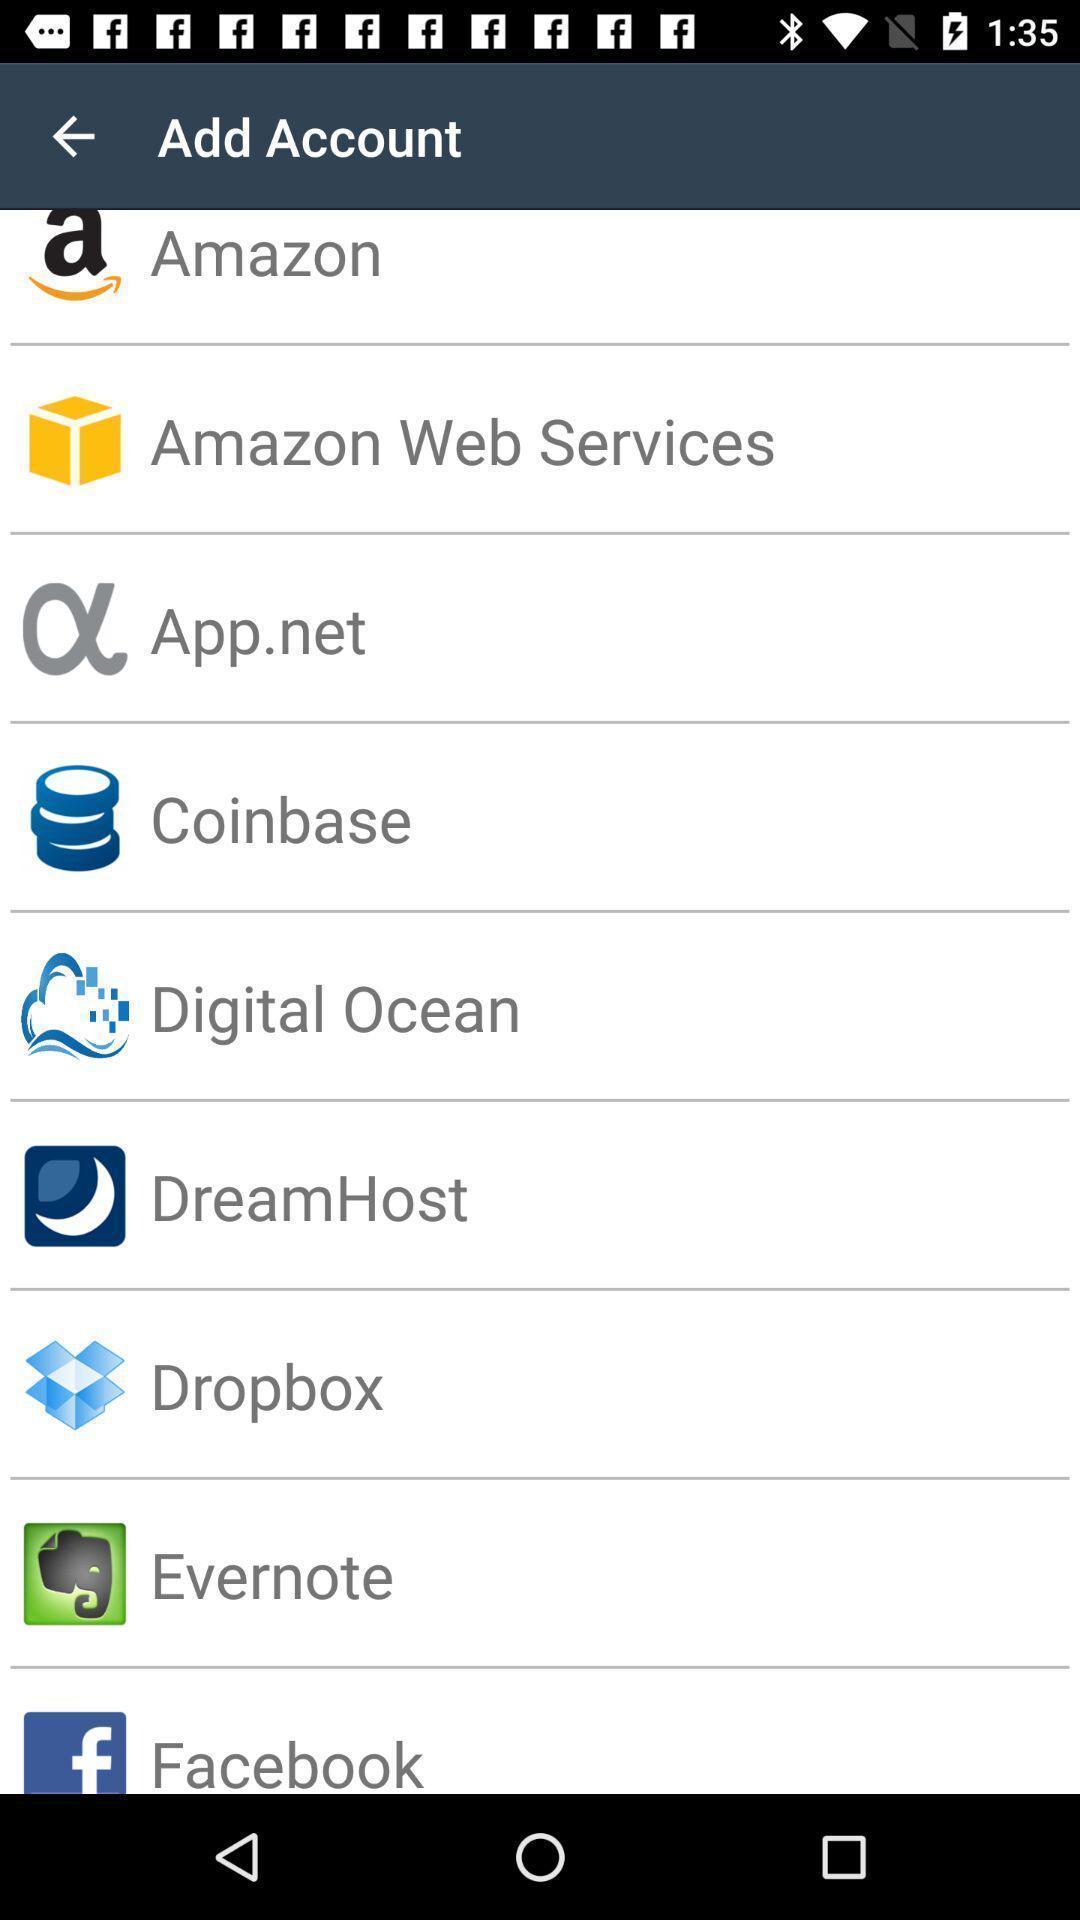Tell me what you see in this picture. Page to add account from the list. 